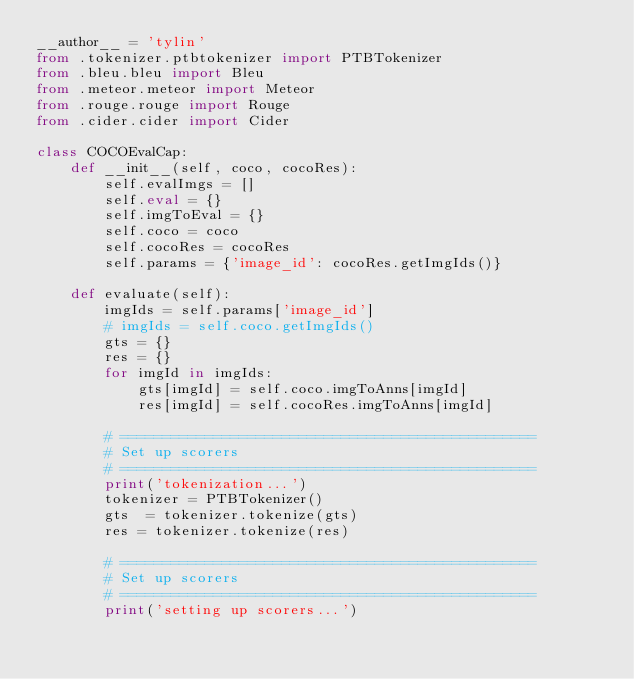<code> <loc_0><loc_0><loc_500><loc_500><_Python_>__author__ = 'tylin'
from .tokenizer.ptbtokenizer import PTBTokenizer
from .bleu.bleu import Bleu
from .meteor.meteor import Meteor
from .rouge.rouge import Rouge
from .cider.cider import Cider

class COCOEvalCap:
    def __init__(self, coco, cocoRes):
        self.evalImgs = []
        self.eval = {}
        self.imgToEval = {}
        self.coco = coco
        self.cocoRes = cocoRes
        self.params = {'image_id': cocoRes.getImgIds()}

    def evaluate(self):
        imgIds = self.params['image_id']
        # imgIds = self.coco.getImgIds()
        gts = {}
        res = {}
        for imgId in imgIds:
            gts[imgId] = self.coco.imgToAnns[imgId]
            res[imgId] = self.cocoRes.imgToAnns[imgId]

        # =================================================
        # Set up scorers
        # =================================================
        print('tokenization...')
        tokenizer = PTBTokenizer()
        gts  = tokenizer.tokenize(gts)
        res = tokenizer.tokenize(res)

        # =================================================
        # Set up scorers
        # =================================================
        print('setting up scorers...')</code> 